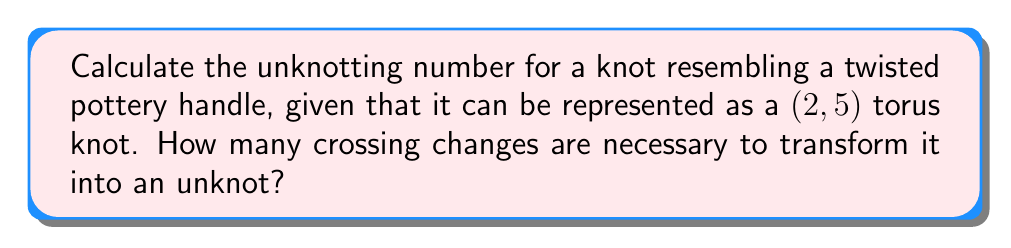Help me with this question. Let's approach this step-by-step:

1) First, we need to understand what a (2,5) torus knot is. It's a knot that winds around a torus 2 times in one direction and 5 times in the other.

2) For torus knots, there's a general formula for the unknotting number:

   $$u(T(p,q)) = \frac{(p-1)(q-1)}{2}$$

   where $T(p,q)$ represents a (p,q) torus knot, and $u$ is the unknotting number.

3) In our case, we have a (2,5) torus knot, so $p=2$ and $q=5$.

4) Let's substitute these values into our formula:

   $$u(T(2,5)) = \frac{(2-1)(5-1)}{2}$$

5) Simplify:
   $$u(T(2,5)) = \frac{1 \cdot 4}{2} = \frac{4}{2} = 2$$

6) Therefore, the unknotting number for this knot is 2, meaning it takes 2 crossing changes to transform it into an unknot.

This result aligns with the pottery context: imagine a twisted handle that needs to be "untwisted" twice to become a simple loop.
Answer: 2 